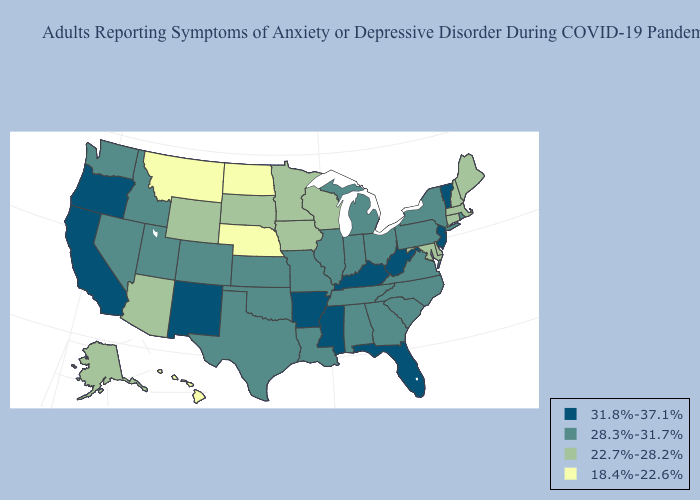Name the states that have a value in the range 18.4%-22.6%?
Keep it brief. Hawaii, Montana, Nebraska, North Dakota. What is the highest value in the USA?
Answer briefly. 31.8%-37.1%. Which states have the lowest value in the USA?
Quick response, please. Hawaii, Montana, Nebraska, North Dakota. Name the states that have a value in the range 31.8%-37.1%?
Give a very brief answer. Arkansas, California, Florida, Kentucky, Mississippi, New Jersey, New Mexico, Oregon, Vermont, West Virginia. Does Utah have the highest value in the USA?
Concise answer only. No. What is the value of Montana?
Keep it brief. 18.4%-22.6%. What is the lowest value in the USA?
Be succinct. 18.4%-22.6%. Name the states that have a value in the range 22.7%-28.2%?
Be succinct. Alaska, Arizona, Connecticut, Delaware, Iowa, Maine, Maryland, Massachusetts, Minnesota, New Hampshire, South Dakota, Wisconsin, Wyoming. Does the map have missing data?
Give a very brief answer. No. Is the legend a continuous bar?
Be succinct. No. Does the first symbol in the legend represent the smallest category?
Short answer required. No. What is the highest value in the USA?
Quick response, please. 31.8%-37.1%. Among the states that border Vermont , which have the lowest value?
Answer briefly. Massachusetts, New Hampshire. Among the states that border California , which have the lowest value?
Short answer required. Arizona. What is the value of Maryland?
Keep it brief. 22.7%-28.2%. 